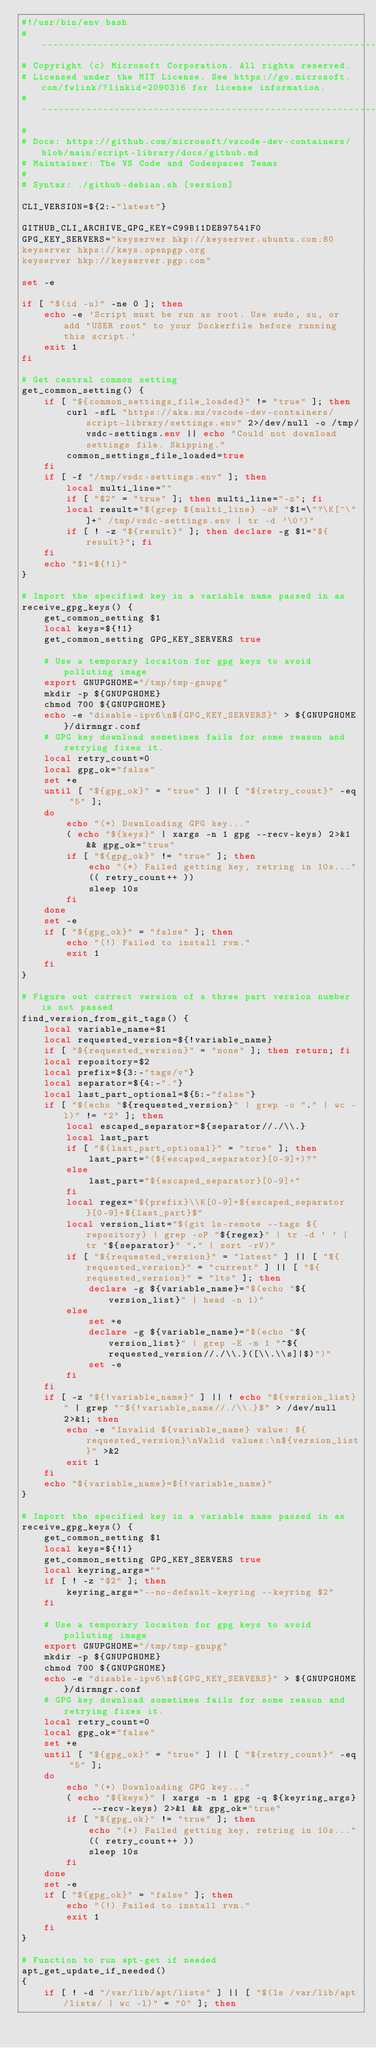<code> <loc_0><loc_0><loc_500><loc_500><_Bash_>#!/usr/bin/env bash
#-------------------------------------------------------------------------------------------------------------
# Copyright (c) Microsoft Corporation. All rights reserved.
# Licensed under the MIT License. See https://go.microsoft.com/fwlink/?linkid=2090316 for license information.
#-------------------------------------------------------------------------------------------------------------
#
# Docs: https://github.com/microsoft/vscode-dev-containers/blob/main/script-library/docs/github.md
# Maintainer: The VS Code and Codespaces Teams
#
# Syntax: ./github-debian.sh [version]

CLI_VERSION=${2:-"latest"}

GITHUB_CLI_ARCHIVE_GPG_KEY=C99B11DEB97541F0
GPG_KEY_SERVERS="keyserver hkp://keyserver.ubuntu.com:80
keyserver hkps://keys.openpgp.org
keyserver hkp://keyserver.pgp.com"

set -e

if [ "$(id -u)" -ne 0 ]; then
    echo -e 'Script must be run as root. Use sudo, su, or add "USER root" to your Dockerfile before running this script.'
    exit 1
fi

# Get central common setting
get_common_setting() {
    if [ "${common_settings_file_loaded}" != "true" ]; then
        curl -sfL "https://aka.ms/vscode-dev-containers/script-library/settings.env" 2>/dev/null -o /tmp/vsdc-settings.env || echo "Could not download settings file. Skipping."
        common_settings_file_loaded=true
    fi
    if [ -f "/tmp/vsdc-settings.env" ]; then
        local multi_line=""
        if [ "$2" = "true" ]; then multi_line="-z"; fi
        local result="$(grep ${multi_line} -oP "$1=\"?\K[^\"]+" /tmp/vsdc-settings.env | tr -d '\0')"
        if [ ! -z "${result}" ]; then declare -g $1="${result}"; fi
    fi
    echo "$1=${!1}"
}

# Import the specified key in a variable name passed in as 
receive_gpg_keys() {
    get_common_setting $1
    local keys=${!1}
    get_common_setting GPG_KEY_SERVERS true

    # Use a temporary locaiton for gpg keys to avoid polluting image
    export GNUPGHOME="/tmp/tmp-gnupg"
    mkdir -p ${GNUPGHOME}
    chmod 700 ${GNUPGHOME}
    echo -e "disable-ipv6\n${GPG_KEY_SERVERS}" > ${GNUPGHOME}/dirmngr.conf
    # GPG key download sometimes fails for some reason and retrying fixes it.
    local retry_count=0
    local gpg_ok="false"
    set +e
    until [ "${gpg_ok}" = "true" ] || [ "${retry_count}" -eq "5" ]; 
    do
        echo "(*) Downloading GPG key..."
        ( echo "${keys}" | xargs -n 1 gpg --recv-keys) 2>&1 && gpg_ok="true"
        if [ "${gpg_ok}" != "true" ]; then
            echo "(*) Failed getting key, retring in 10s..."
            (( retry_count++ ))
            sleep 10s
        fi
    done
    set -e
    if [ "${gpg_ok}" = "false" ]; then
        echo "(!) Failed to install rvm."
        exit 1
    fi
}

# Figure out correct version of a three part version number is not passed
find_version_from_git_tags() {
    local variable_name=$1
    local requested_version=${!variable_name}
    if [ "${requested_version}" = "none" ]; then return; fi
    local repository=$2
    local prefix=${3:-"tags/v"}
    local separator=${4:-"."}
    local last_part_optional=${5:-"false"}    
    if [ "$(echo "${requested_version}" | grep -o "." | wc -l)" != "2" ]; then
        local escaped_separator=${separator//./\\.}
        local last_part
        if [ "${last_part_optional}" = "true" ]; then
            last_part="(${escaped_separator}[0-9]+)?"
        else
            last_part="${escaped_separator}[0-9]+"
        fi
        local regex="${prefix}\\K[0-9]+${escaped_separator}[0-9]+${last_part}$"
        local version_list="$(git ls-remote --tags ${repository} | grep -oP "${regex}" | tr -d ' ' | tr "${separator}" "." | sort -rV)"
        if [ "${requested_version}" = "latest" ] || [ "${requested_version}" = "current" ] || [ "${requested_version}" = "lts" ]; then
            declare -g ${variable_name}="$(echo "${version_list}" | head -n 1)"
        else
            set +e
            declare -g ${variable_name}="$(echo "${version_list}" | grep -E -m 1 "^${requested_version//./\\.}([\\.\\s]|$)")"
            set -e
        fi
    fi
    if [ -z "${!variable_name}" ] || ! echo "${version_list}" | grep "^${!variable_name//./\\.}$" > /dev/null 2>&1; then
        echo -e "Invalid ${variable_name} value: ${requested_version}\nValid values:\n${version_list}" >&2
        exit 1
    fi
    echo "${variable_name}=${!variable_name}"
}

# Import the specified key in a variable name passed in as 
receive_gpg_keys() {
    get_common_setting $1
    local keys=${!1}
    get_common_setting GPG_KEY_SERVERS true
    local keyring_args=""
    if [ ! -z "$2" ]; then
        keyring_args="--no-default-keyring --keyring $2"
    fi

    # Use a temporary locaiton for gpg keys to avoid polluting image
    export GNUPGHOME="/tmp/tmp-gnupg"
    mkdir -p ${GNUPGHOME}
    chmod 700 ${GNUPGHOME}
    echo -e "disable-ipv6\n${GPG_KEY_SERVERS}" > ${GNUPGHOME}/dirmngr.conf
    # GPG key download sometimes fails for some reason and retrying fixes it.
    local retry_count=0
    local gpg_ok="false"
    set +e
    until [ "${gpg_ok}" = "true" ] || [ "${retry_count}" -eq "5" ]; 
    do
        echo "(*) Downloading GPG key..."
        ( echo "${keys}" | xargs -n 1 gpg -q ${keyring_args} --recv-keys) 2>&1 && gpg_ok="true"
        if [ "${gpg_ok}" != "true" ]; then
            echo "(*) Failed getting key, retring in 10s..."
            (( retry_count++ ))
            sleep 10s
        fi
    done
    set -e
    if [ "${gpg_ok}" = "false" ]; then
        echo "(!) Failed to install rvm."
        exit 1
    fi
}

# Function to run apt-get if needed
apt_get_update_if_needed()
{
    if [ ! -d "/var/lib/apt/lists" ] || [ "$(ls /var/lib/apt/lists/ | wc -l)" = "0" ]; then</code> 